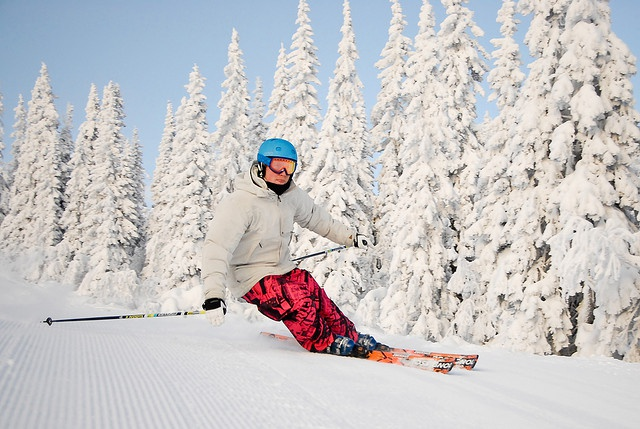Describe the objects in this image and their specific colors. I can see people in gray, lightgray, darkgray, and black tones and skis in gray, lightgray, darkgray, lightpink, and salmon tones in this image. 